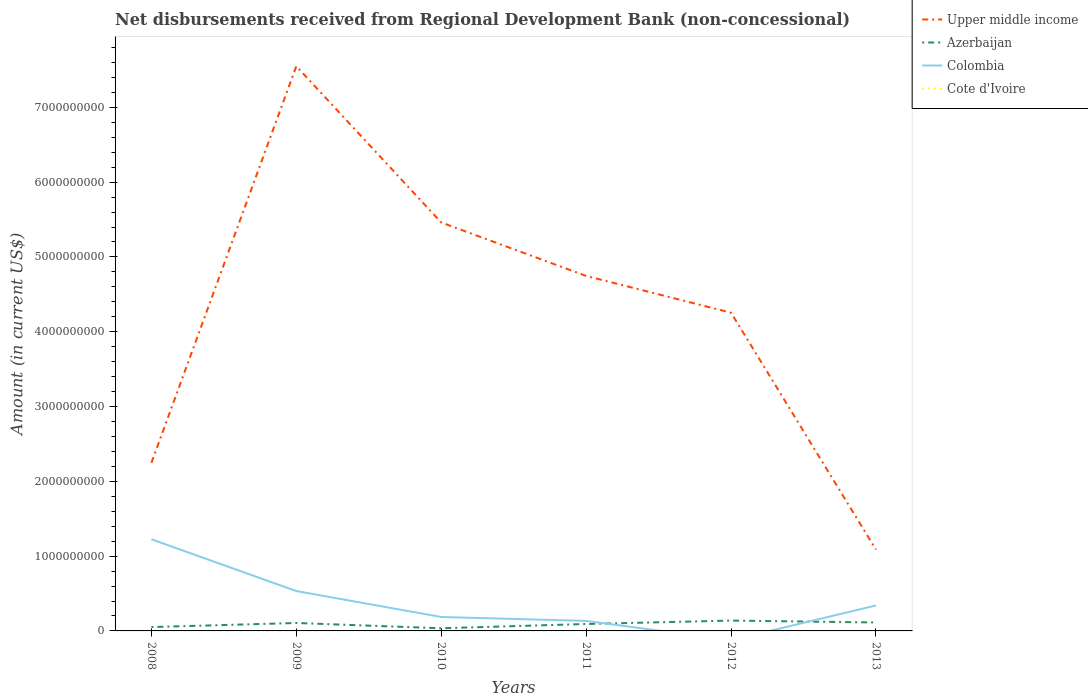Does the line corresponding to Azerbaijan intersect with the line corresponding to Colombia?
Offer a very short reply. Yes. Across all years, what is the maximum amount of disbursements received from Regional Development Bank in Upper middle income?
Ensure brevity in your answer.  1.09e+09. What is the total amount of disbursements received from Regional Development Bank in Azerbaijan in the graph?
Offer a very short reply. 1.35e+07. What is the difference between the highest and the second highest amount of disbursements received from Regional Development Bank in Colombia?
Your answer should be very brief. 1.23e+09. Is the amount of disbursements received from Regional Development Bank in Azerbaijan strictly greater than the amount of disbursements received from Regional Development Bank in Colombia over the years?
Offer a very short reply. No. What is the difference between two consecutive major ticks on the Y-axis?
Your answer should be compact. 1.00e+09. Does the graph contain any zero values?
Ensure brevity in your answer.  Yes. Where does the legend appear in the graph?
Offer a very short reply. Top right. How are the legend labels stacked?
Ensure brevity in your answer.  Vertical. What is the title of the graph?
Offer a terse response. Net disbursements received from Regional Development Bank (non-concessional). Does "Czech Republic" appear as one of the legend labels in the graph?
Your response must be concise. No. What is the label or title of the X-axis?
Offer a terse response. Years. What is the Amount (in current US$) of Upper middle income in 2008?
Your answer should be very brief. 2.25e+09. What is the Amount (in current US$) in Azerbaijan in 2008?
Give a very brief answer. 5.16e+07. What is the Amount (in current US$) of Colombia in 2008?
Offer a very short reply. 1.23e+09. What is the Amount (in current US$) in Upper middle income in 2009?
Make the answer very short. 7.55e+09. What is the Amount (in current US$) of Azerbaijan in 2009?
Ensure brevity in your answer.  1.06e+08. What is the Amount (in current US$) of Colombia in 2009?
Provide a short and direct response. 5.33e+08. What is the Amount (in current US$) in Cote d'Ivoire in 2009?
Give a very brief answer. 0. What is the Amount (in current US$) in Upper middle income in 2010?
Provide a short and direct response. 5.46e+09. What is the Amount (in current US$) in Azerbaijan in 2010?
Provide a short and direct response. 3.55e+07. What is the Amount (in current US$) in Colombia in 2010?
Your answer should be compact. 1.86e+08. What is the Amount (in current US$) of Cote d'Ivoire in 2010?
Give a very brief answer. 0. What is the Amount (in current US$) of Upper middle income in 2011?
Your answer should be compact. 4.75e+09. What is the Amount (in current US$) in Azerbaijan in 2011?
Provide a short and direct response. 9.27e+07. What is the Amount (in current US$) of Colombia in 2011?
Your response must be concise. 1.34e+08. What is the Amount (in current US$) of Cote d'Ivoire in 2011?
Provide a succinct answer. 0. What is the Amount (in current US$) in Upper middle income in 2012?
Keep it short and to the point. 4.25e+09. What is the Amount (in current US$) of Azerbaijan in 2012?
Offer a terse response. 1.38e+08. What is the Amount (in current US$) in Cote d'Ivoire in 2012?
Make the answer very short. 0. What is the Amount (in current US$) in Upper middle income in 2013?
Keep it short and to the point. 1.09e+09. What is the Amount (in current US$) of Azerbaijan in 2013?
Offer a terse response. 1.13e+08. What is the Amount (in current US$) in Colombia in 2013?
Your answer should be compact. 3.40e+08. Across all years, what is the maximum Amount (in current US$) of Upper middle income?
Provide a succinct answer. 7.55e+09. Across all years, what is the maximum Amount (in current US$) of Azerbaijan?
Make the answer very short. 1.38e+08. Across all years, what is the maximum Amount (in current US$) of Colombia?
Your answer should be compact. 1.23e+09. Across all years, what is the minimum Amount (in current US$) in Upper middle income?
Your response must be concise. 1.09e+09. Across all years, what is the minimum Amount (in current US$) in Azerbaijan?
Your answer should be compact. 3.55e+07. Across all years, what is the minimum Amount (in current US$) in Colombia?
Your answer should be compact. 0. What is the total Amount (in current US$) in Upper middle income in the graph?
Provide a succinct answer. 2.53e+1. What is the total Amount (in current US$) of Azerbaijan in the graph?
Your response must be concise. 5.37e+08. What is the total Amount (in current US$) in Colombia in the graph?
Your response must be concise. 2.42e+09. What is the difference between the Amount (in current US$) in Upper middle income in 2008 and that in 2009?
Ensure brevity in your answer.  -5.30e+09. What is the difference between the Amount (in current US$) of Azerbaijan in 2008 and that in 2009?
Offer a very short reply. -5.45e+07. What is the difference between the Amount (in current US$) in Colombia in 2008 and that in 2009?
Your answer should be very brief. 6.92e+08. What is the difference between the Amount (in current US$) of Upper middle income in 2008 and that in 2010?
Your response must be concise. -3.21e+09. What is the difference between the Amount (in current US$) of Azerbaijan in 2008 and that in 2010?
Keep it short and to the point. 1.62e+07. What is the difference between the Amount (in current US$) of Colombia in 2008 and that in 2010?
Provide a short and direct response. 1.04e+09. What is the difference between the Amount (in current US$) in Upper middle income in 2008 and that in 2011?
Keep it short and to the point. -2.50e+09. What is the difference between the Amount (in current US$) in Azerbaijan in 2008 and that in 2011?
Offer a very short reply. -4.10e+07. What is the difference between the Amount (in current US$) of Colombia in 2008 and that in 2011?
Keep it short and to the point. 1.09e+09. What is the difference between the Amount (in current US$) of Upper middle income in 2008 and that in 2012?
Make the answer very short. -2.01e+09. What is the difference between the Amount (in current US$) of Azerbaijan in 2008 and that in 2012?
Provide a short and direct response. -8.67e+07. What is the difference between the Amount (in current US$) in Upper middle income in 2008 and that in 2013?
Offer a terse response. 1.16e+09. What is the difference between the Amount (in current US$) of Azerbaijan in 2008 and that in 2013?
Offer a terse response. -6.13e+07. What is the difference between the Amount (in current US$) of Colombia in 2008 and that in 2013?
Your response must be concise. 8.85e+08. What is the difference between the Amount (in current US$) of Upper middle income in 2009 and that in 2010?
Offer a very short reply. 2.09e+09. What is the difference between the Amount (in current US$) of Azerbaijan in 2009 and that in 2010?
Give a very brief answer. 7.07e+07. What is the difference between the Amount (in current US$) in Colombia in 2009 and that in 2010?
Keep it short and to the point. 3.47e+08. What is the difference between the Amount (in current US$) in Upper middle income in 2009 and that in 2011?
Offer a terse response. 2.80e+09. What is the difference between the Amount (in current US$) in Azerbaijan in 2009 and that in 2011?
Your answer should be compact. 1.35e+07. What is the difference between the Amount (in current US$) of Colombia in 2009 and that in 2011?
Your answer should be very brief. 4.00e+08. What is the difference between the Amount (in current US$) in Upper middle income in 2009 and that in 2012?
Give a very brief answer. 3.30e+09. What is the difference between the Amount (in current US$) in Azerbaijan in 2009 and that in 2012?
Offer a terse response. -3.22e+07. What is the difference between the Amount (in current US$) in Upper middle income in 2009 and that in 2013?
Ensure brevity in your answer.  6.46e+09. What is the difference between the Amount (in current US$) in Azerbaijan in 2009 and that in 2013?
Give a very brief answer. -6.74e+06. What is the difference between the Amount (in current US$) of Colombia in 2009 and that in 2013?
Your response must be concise. 1.93e+08. What is the difference between the Amount (in current US$) of Upper middle income in 2010 and that in 2011?
Offer a very short reply. 7.15e+08. What is the difference between the Amount (in current US$) of Azerbaijan in 2010 and that in 2011?
Make the answer very short. -5.72e+07. What is the difference between the Amount (in current US$) in Colombia in 2010 and that in 2011?
Your response must be concise. 5.28e+07. What is the difference between the Amount (in current US$) in Upper middle income in 2010 and that in 2012?
Provide a short and direct response. 1.21e+09. What is the difference between the Amount (in current US$) in Azerbaijan in 2010 and that in 2012?
Provide a short and direct response. -1.03e+08. What is the difference between the Amount (in current US$) in Upper middle income in 2010 and that in 2013?
Your response must be concise. 4.37e+09. What is the difference between the Amount (in current US$) of Azerbaijan in 2010 and that in 2013?
Give a very brief answer. -7.74e+07. What is the difference between the Amount (in current US$) of Colombia in 2010 and that in 2013?
Offer a very short reply. -1.54e+08. What is the difference between the Amount (in current US$) of Upper middle income in 2011 and that in 2012?
Make the answer very short. 4.92e+08. What is the difference between the Amount (in current US$) of Azerbaijan in 2011 and that in 2012?
Your answer should be compact. -4.56e+07. What is the difference between the Amount (in current US$) in Upper middle income in 2011 and that in 2013?
Keep it short and to the point. 3.66e+09. What is the difference between the Amount (in current US$) of Azerbaijan in 2011 and that in 2013?
Your response must be concise. -2.02e+07. What is the difference between the Amount (in current US$) in Colombia in 2011 and that in 2013?
Give a very brief answer. -2.07e+08. What is the difference between the Amount (in current US$) of Upper middle income in 2012 and that in 2013?
Make the answer very short. 3.17e+09. What is the difference between the Amount (in current US$) in Azerbaijan in 2012 and that in 2013?
Your answer should be compact. 2.54e+07. What is the difference between the Amount (in current US$) in Upper middle income in 2008 and the Amount (in current US$) in Azerbaijan in 2009?
Keep it short and to the point. 2.14e+09. What is the difference between the Amount (in current US$) of Upper middle income in 2008 and the Amount (in current US$) of Colombia in 2009?
Your answer should be very brief. 1.71e+09. What is the difference between the Amount (in current US$) of Azerbaijan in 2008 and the Amount (in current US$) of Colombia in 2009?
Offer a terse response. -4.82e+08. What is the difference between the Amount (in current US$) of Upper middle income in 2008 and the Amount (in current US$) of Azerbaijan in 2010?
Ensure brevity in your answer.  2.21e+09. What is the difference between the Amount (in current US$) in Upper middle income in 2008 and the Amount (in current US$) in Colombia in 2010?
Give a very brief answer. 2.06e+09. What is the difference between the Amount (in current US$) of Azerbaijan in 2008 and the Amount (in current US$) of Colombia in 2010?
Provide a short and direct response. -1.35e+08. What is the difference between the Amount (in current US$) of Upper middle income in 2008 and the Amount (in current US$) of Azerbaijan in 2011?
Your response must be concise. 2.15e+09. What is the difference between the Amount (in current US$) of Upper middle income in 2008 and the Amount (in current US$) of Colombia in 2011?
Give a very brief answer. 2.11e+09. What is the difference between the Amount (in current US$) of Azerbaijan in 2008 and the Amount (in current US$) of Colombia in 2011?
Ensure brevity in your answer.  -8.20e+07. What is the difference between the Amount (in current US$) in Upper middle income in 2008 and the Amount (in current US$) in Azerbaijan in 2012?
Provide a short and direct response. 2.11e+09. What is the difference between the Amount (in current US$) of Upper middle income in 2008 and the Amount (in current US$) of Azerbaijan in 2013?
Your response must be concise. 2.13e+09. What is the difference between the Amount (in current US$) in Upper middle income in 2008 and the Amount (in current US$) in Colombia in 2013?
Give a very brief answer. 1.91e+09. What is the difference between the Amount (in current US$) of Azerbaijan in 2008 and the Amount (in current US$) of Colombia in 2013?
Provide a short and direct response. -2.89e+08. What is the difference between the Amount (in current US$) in Upper middle income in 2009 and the Amount (in current US$) in Azerbaijan in 2010?
Make the answer very short. 7.51e+09. What is the difference between the Amount (in current US$) of Upper middle income in 2009 and the Amount (in current US$) of Colombia in 2010?
Provide a succinct answer. 7.36e+09. What is the difference between the Amount (in current US$) in Azerbaijan in 2009 and the Amount (in current US$) in Colombia in 2010?
Make the answer very short. -8.02e+07. What is the difference between the Amount (in current US$) in Upper middle income in 2009 and the Amount (in current US$) in Azerbaijan in 2011?
Your answer should be compact. 7.46e+09. What is the difference between the Amount (in current US$) of Upper middle income in 2009 and the Amount (in current US$) of Colombia in 2011?
Your answer should be compact. 7.42e+09. What is the difference between the Amount (in current US$) of Azerbaijan in 2009 and the Amount (in current US$) of Colombia in 2011?
Provide a short and direct response. -2.75e+07. What is the difference between the Amount (in current US$) of Upper middle income in 2009 and the Amount (in current US$) of Azerbaijan in 2012?
Give a very brief answer. 7.41e+09. What is the difference between the Amount (in current US$) of Upper middle income in 2009 and the Amount (in current US$) of Azerbaijan in 2013?
Provide a succinct answer. 7.44e+09. What is the difference between the Amount (in current US$) in Upper middle income in 2009 and the Amount (in current US$) in Colombia in 2013?
Give a very brief answer. 7.21e+09. What is the difference between the Amount (in current US$) of Azerbaijan in 2009 and the Amount (in current US$) of Colombia in 2013?
Ensure brevity in your answer.  -2.34e+08. What is the difference between the Amount (in current US$) in Upper middle income in 2010 and the Amount (in current US$) in Azerbaijan in 2011?
Offer a terse response. 5.37e+09. What is the difference between the Amount (in current US$) in Upper middle income in 2010 and the Amount (in current US$) in Colombia in 2011?
Provide a succinct answer. 5.33e+09. What is the difference between the Amount (in current US$) of Azerbaijan in 2010 and the Amount (in current US$) of Colombia in 2011?
Make the answer very short. -9.81e+07. What is the difference between the Amount (in current US$) in Upper middle income in 2010 and the Amount (in current US$) in Azerbaijan in 2012?
Provide a short and direct response. 5.32e+09. What is the difference between the Amount (in current US$) in Upper middle income in 2010 and the Amount (in current US$) in Azerbaijan in 2013?
Make the answer very short. 5.35e+09. What is the difference between the Amount (in current US$) in Upper middle income in 2010 and the Amount (in current US$) in Colombia in 2013?
Your response must be concise. 5.12e+09. What is the difference between the Amount (in current US$) of Azerbaijan in 2010 and the Amount (in current US$) of Colombia in 2013?
Ensure brevity in your answer.  -3.05e+08. What is the difference between the Amount (in current US$) in Upper middle income in 2011 and the Amount (in current US$) in Azerbaijan in 2012?
Offer a very short reply. 4.61e+09. What is the difference between the Amount (in current US$) of Upper middle income in 2011 and the Amount (in current US$) of Azerbaijan in 2013?
Your answer should be very brief. 4.63e+09. What is the difference between the Amount (in current US$) in Upper middle income in 2011 and the Amount (in current US$) in Colombia in 2013?
Offer a very short reply. 4.41e+09. What is the difference between the Amount (in current US$) in Azerbaijan in 2011 and the Amount (in current US$) in Colombia in 2013?
Offer a very short reply. -2.48e+08. What is the difference between the Amount (in current US$) of Upper middle income in 2012 and the Amount (in current US$) of Azerbaijan in 2013?
Offer a very short reply. 4.14e+09. What is the difference between the Amount (in current US$) in Upper middle income in 2012 and the Amount (in current US$) in Colombia in 2013?
Provide a succinct answer. 3.91e+09. What is the difference between the Amount (in current US$) of Azerbaijan in 2012 and the Amount (in current US$) of Colombia in 2013?
Make the answer very short. -2.02e+08. What is the average Amount (in current US$) of Upper middle income per year?
Provide a short and direct response. 4.22e+09. What is the average Amount (in current US$) of Azerbaijan per year?
Keep it short and to the point. 8.95e+07. What is the average Amount (in current US$) of Colombia per year?
Your answer should be very brief. 4.03e+08. What is the average Amount (in current US$) in Cote d'Ivoire per year?
Keep it short and to the point. 0. In the year 2008, what is the difference between the Amount (in current US$) of Upper middle income and Amount (in current US$) of Azerbaijan?
Offer a very short reply. 2.20e+09. In the year 2008, what is the difference between the Amount (in current US$) in Upper middle income and Amount (in current US$) in Colombia?
Your response must be concise. 1.02e+09. In the year 2008, what is the difference between the Amount (in current US$) in Azerbaijan and Amount (in current US$) in Colombia?
Provide a succinct answer. -1.17e+09. In the year 2009, what is the difference between the Amount (in current US$) in Upper middle income and Amount (in current US$) in Azerbaijan?
Provide a short and direct response. 7.44e+09. In the year 2009, what is the difference between the Amount (in current US$) of Upper middle income and Amount (in current US$) of Colombia?
Your answer should be very brief. 7.02e+09. In the year 2009, what is the difference between the Amount (in current US$) of Azerbaijan and Amount (in current US$) of Colombia?
Your answer should be very brief. -4.27e+08. In the year 2010, what is the difference between the Amount (in current US$) of Upper middle income and Amount (in current US$) of Azerbaijan?
Give a very brief answer. 5.43e+09. In the year 2010, what is the difference between the Amount (in current US$) in Upper middle income and Amount (in current US$) in Colombia?
Provide a succinct answer. 5.27e+09. In the year 2010, what is the difference between the Amount (in current US$) of Azerbaijan and Amount (in current US$) of Colombia?
Make the answer very short. -1.51e+08. In the year 2011, what is the difference between the Amount (in current US$) in Upper middle income and Amount (in current US$) in Azerbaijan?
Keep it short and to the point. 4.65e+09. In the year 2011, what is the difference between the Amount (in current US$) in Upper middle income and Amount (in current US$) in Colombia?
Provide a short and direct response. 4.61e+09. In the year 2011, what is the difference between the Amount (in current US$) of Azerbaijan and Amount (in current US$) of Colombia?
Your answer should be compact. -4.10e+07. In the year 2012, what is the difference between the Amount (in current US$) of Upper middle income and Amount (in current US$) of Azerbaijan?
Make the answer very short. 4.12e+09. In the year 2013, what is the difference between the Amount (in current US$) of Upper middle income and Amount (in current US$) of Azerbaijan?
Provide a succinct answer. 9.75e+08. In the year 2013, what is the difference between the Amount (in current US$) of Upper middle income and Amount (in current US$) of Colombia?
Make the answer very short. 7.48e+08. In the year 2013, what is the difference between the Amount (in current US$) in Azerbaijan and Amount (in current US$) in Colombia?
Provide a succinct answer. -2.27e+08. What is the ratio of the Amount (in current US$) of Upper middle income in 2008 to that in 2009?
Your answer should be compact. 0.3. What is the ratio of the Amount (in current US$) of Azerbaijan in 2008 to that in 2009?
Offer a terse response. 0.49. What is the ratio of the Amount (in current US$) of Colombia in 2008 to that in 2009?
Keep it short and to the point. 2.3. What is the ratio of the Amount (in current US$) of Upper middle income in 2008 to that in 2010?
Your answer should be very brief. 0.41. What is the ratio of the Amount (in current US$) in Azerbaijan in 2008 to that in 2010?
Your response must be concise. 1.46. What is the ratio of the Amount (in current US$) of Colombia in 2008 to that in 2010?
Provide a short and direct response. 6.57. What is the ratio of the Amount (in current US$) of Upper middle income in 2008 to that in 2011?
Keep it short and to the point. 0.47. What is the ratio of the Amount (in current US$) of Azerbaijan in 2008 to that in 2011?
Offer a terse response. 0.56. What is the ratio of the Amount (in current US$) in Colombia in 2008 to that in 2011?
Your answer should be very brief. 9.17. What is the ratio of the Amount (in current US$) of Upper middle income in 2008 to that in 2012?
Provide a succinct answer. 0.53. What is the ratio of the Amount (in current US$) of Azerbaijan in 2008 to that in 2012?
Provide a succinct answer. 0.37. What is the ratio of the Amount (in current US$) of Upper middle income in 2008 to that in 2013?
Give a very brief answer. 2.07. What is the ratio of the Amount (in current US$) in Azerbaijan in 2008 to that in 2013?
Your answer should be very brief. 0.46. What is the ratio of the Amount (in current US$) of Colombia in 2008 to that in 2013?
Your answer should be compact. 3.6. What is the ratio of the Amount (in current US$) of Upper middle income in 2009 to that in 2010?
Provide a succinct answer. 1.38. What is the ratio of the Amount (in current US$) of Azerbaijan in 2009 to that in 2010?
Ensure brevity in your answer.  2.99. What is the ratio of the Amount (in current US$) in Colombia in 2009 to that in 2010?
Offer a terse response. 2.86. What is the ratio of the Amount (in current US$) of Upper middle income in 2009 to that in 2011?
Your response must be concise. 1.59. What is the ratio of the Amount (in current US$) in Azerbaijan in 2009 to that in 2011?
Provide a succinct answer. 1.15. What is the ratio of the Amount (in current US$) in Colombia in 2009 to that in 2011?
Ensure brevity in your answer.  3.99. What is the ratio of the Amount (in current US$) in Upper middle income in 2009 to that in 2012?
Offer a very short reply. 1.77. What is the ratio of the Amount (in current US$) in Azerbaijan in 2009 to that in 2012?
Keep it short and to the point. 0.77. What is the ratio of the Amount (in current US$) of Upper middle income in 2009 to that in 2013?
Keep it short and to the point. 6.94. What is the ratio of the Amount (in current US$) in Azerbaijan in 2009 to that in 2013?
Give a very brief answer. 0.94. What is the ratio of the Amount (in current US$) of Colombia in 2009 to that in 2013?
Your answer should be compact. 1.57. What is the ratio of the Amount (in current US$) in Upper middle income in 2010 to that in 2011?
Make the answer very short. 1.15. What is the ratio of the Amount (in current US$) in Azerbaijan in 2010 to that in 2011?
Keep it short and to the point. 0.38. What is the ratio of the Amount (in current US$) in Colombia in 2010 to that in 2011?
Offer a very short reply. 1.39. What is the ratio of the Amount (in current US$) of Upper middle income in 2010 to that in 2012?
Offer a terse response. 1.28. What is the ratio of the Amount (in current US$) of Azerbaijan in 2010 to that in 2012?
Offer a very short reply. 0.26. What is the ratio of the Amount (in current US$) of Upper middle income in 2010 to that in 2013?
Give a very brief answer. 5.02. What is the ratio of the Amount (in current US$) of Azerbaijan in 2010 to that in 2013?
Keep it short and to the point. 0.31. What is the ratio of the Amount (in current US$) of Colombia in 2010 to that in 2013?
Provide a succinct answer. 0.55. What is the ratio of the Amount (in current US$) in Upper middle income in 2011 to that in 2012?
Make the answer very short. 1.12. What is the ratio of the Amount (in current US$) of Azerbaijan in 2011 to that in 2012?
Offer a terse response. 0.67. What is the ratio of the Amount (in current US$) of Upper middle income in 2011 to that in 2013?
Keep it short and to the point. 4.36. What is the ratio of the Amount (in current US$) in Azerbaijan in 2011 to that in 2013?
Ensure brevity in your answer.  0.82. What is the ratio of the Amount (in current US$) of Colombia in 2011 to that in 2013?
Provide a short and direct response. 0.39. What is the ratio of the Amount (in current US$) of Upper middle income in 2012 to that in 2013?
Offer a terse response. 3.91. What is the ratio of the Amount (in current US$) in Azerbaijan in 2012 to that in 2013?
Your response must be concise. 1.23. What is the difference between the highest and the second highest Amount (in current US$) of Upper middle income?
Keep it short and to the point. 2.09e+09. What is the difference between the highest and the second highest Amount (in current US$) of Azerbaijan?
Provide a short and direct response. 2.54e+07. What is the difference between the highest and the second highest Amount (in current US$) of Colombia?
Offer a terse response. 6.92e+08. What is the difference between the highest and the lowest Amount (in current US$) in Upper middle income?
Offer a terse response. 6.46e+09. What is the difference between the highest and the lowest Amount (in current US$) of Azerbaijan?
Make the answer very short. 1.03e+08. What is the difference between the highest and the lowest Amount (in current US$) of Colombia?
Give a very brief answer. 1.23e+09. 